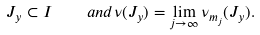Convert formula to latex. <formula><loc_0><loc_0><loc_500><loc_500>J _ { y } \subset I \quad a n d \nu ( J _ { y } ) = \lim _ { j \to \infty } \nu _ { m _ { j } } ( J _ { y } ) .</formula> 